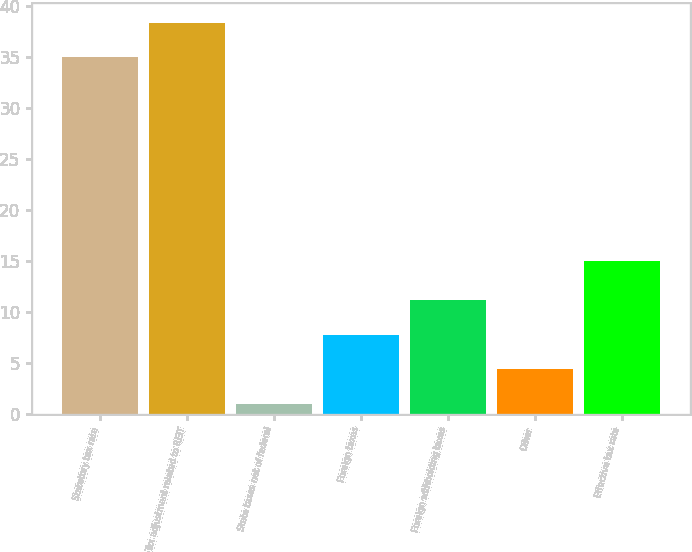Convert chart to OTSL. <chart><loc_0><loc_0><loc_500><loc_500><bar_chart><fcel>Statutory tax rate<fcel>Tax adjustment related to REIT<fcel>State taxes net of federal<fcel>Foreign taxes<fcel>Foreign withholding taxes<fcel>Other<fcel>Effective tax rate<nl><fcel>35<fcel>38.4<fcel>1<fcel>7.8<fcel>11.2<fcel>4.4<fcel>15<nl></chart> 